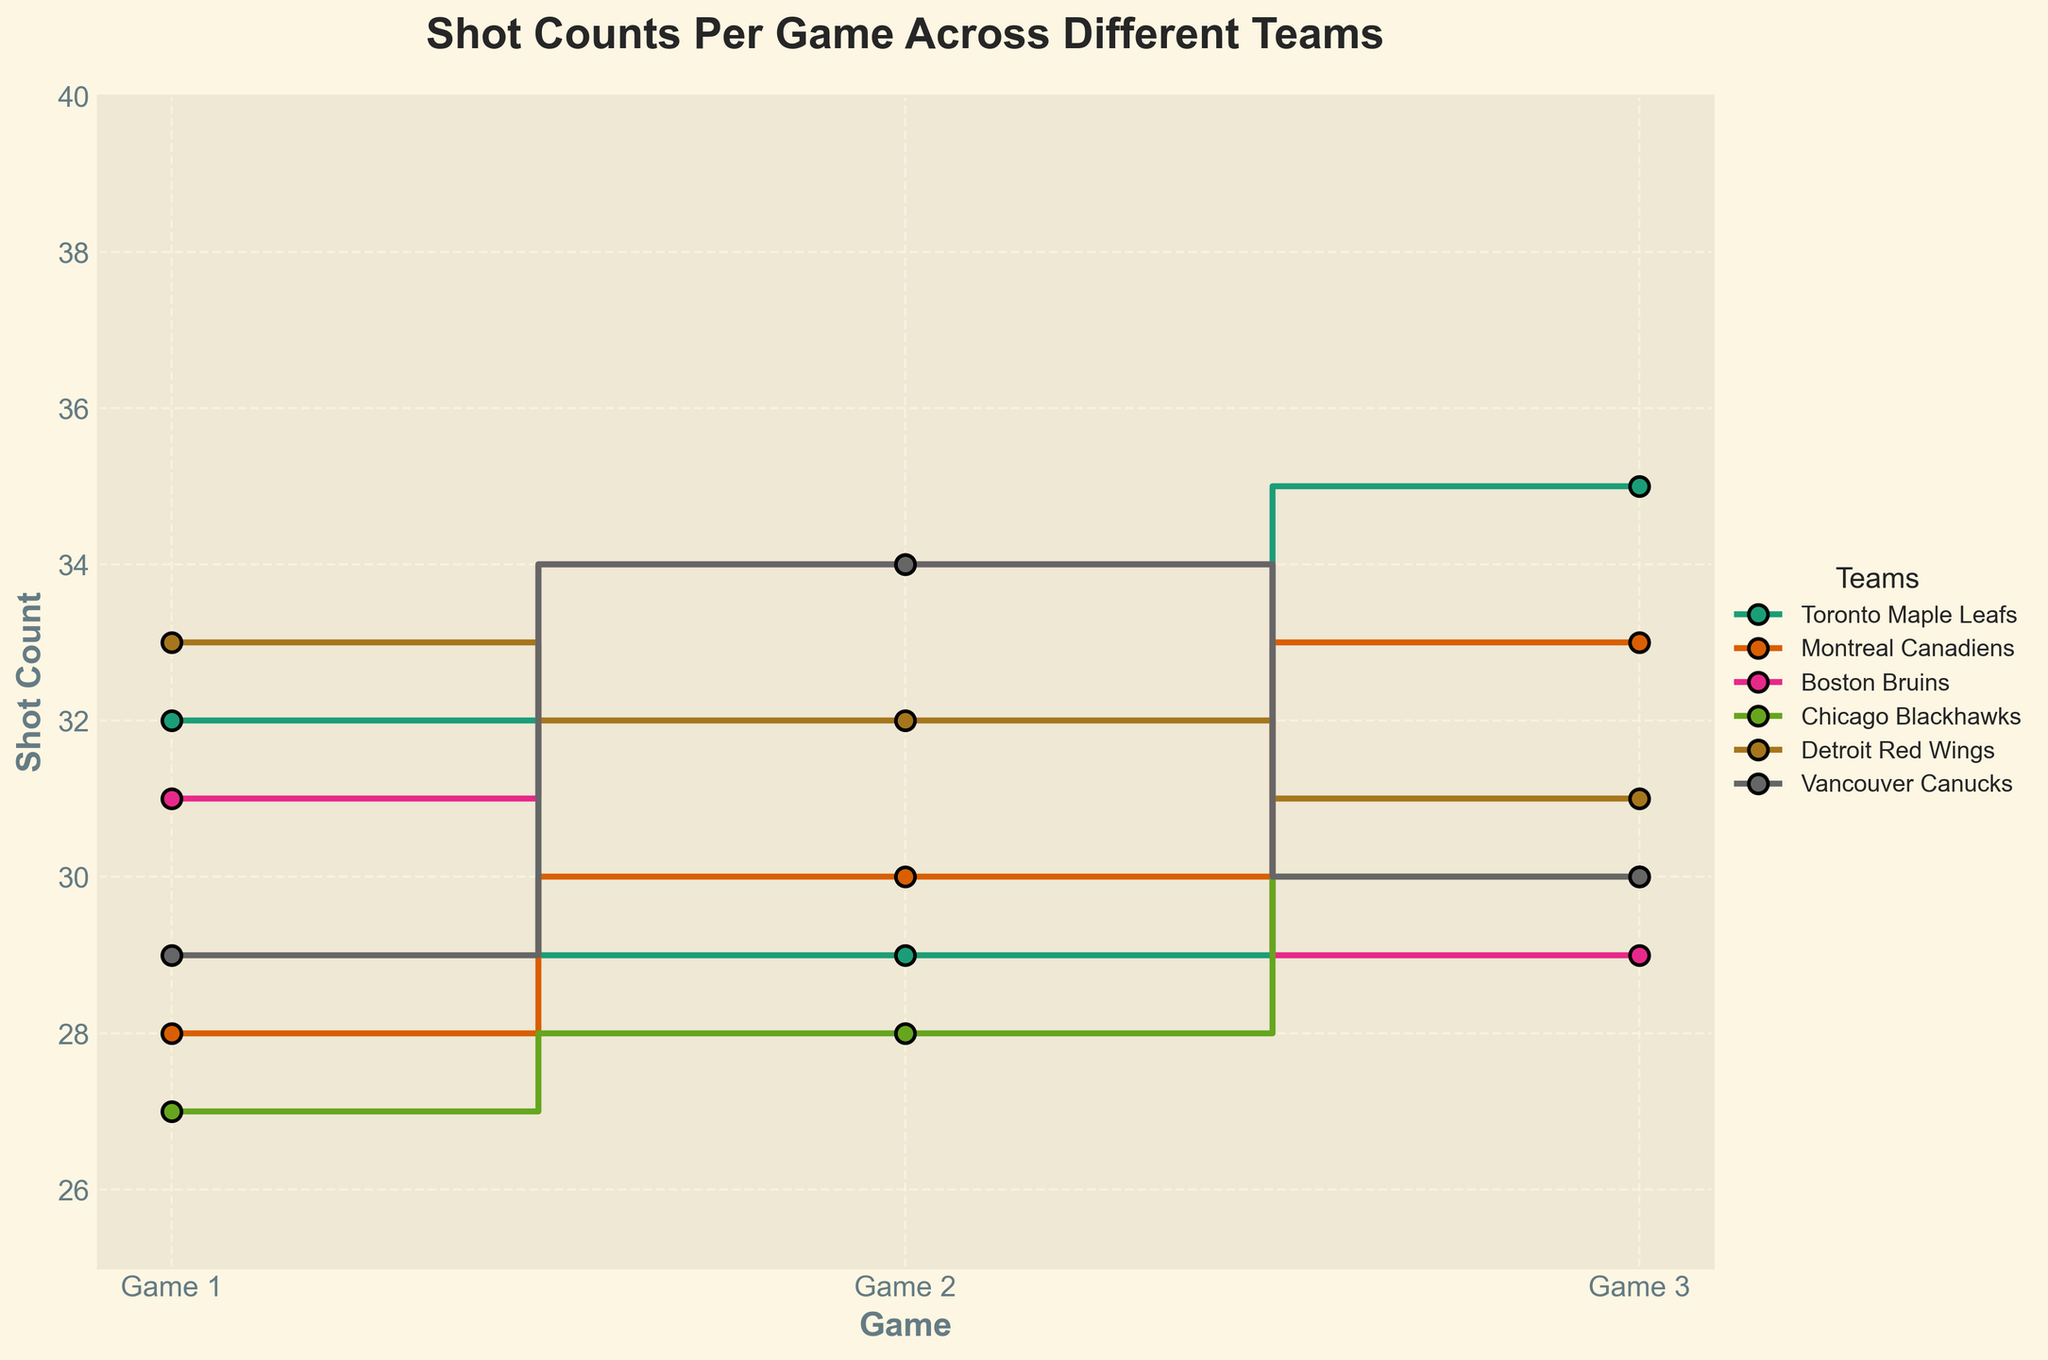Which team had the highest shot count in Game 1? Look for the data corresponding to Game 1 and find the team with the highest value. Toronto Maple Leafs had 32, Montreal Canadiens had 28, Boston Bruins had 31, Chicago Blackhawks had 27, Detroit Red Wings had 33, and Vancouver Canucks had 29. The highest is 33, achieved by Detroit Red Wings.
Answer: Detroit Red Wings Which team showed the most consistent shot count across the three games? Consistency can be judged by the smallest variations between the games. Calgary Flames had shot counts of 32, 29, and 35; counting the differences we get 3, 1, and 6. This process is done for all teams. The Boston Bruins had counts of 31, 34, and 29 with the respective differences being 3, 5, and 2, which averages to 3.33, the smallest average variation hence the most consistent.
Answer: Boston Bruins What is the total shot count for the Chicago Blackhawks across all three games? Sum the shot counts for the Chicago Blackhawks: 27 (Game 1) + 28 (Game 2) + 30 (Game 3) = 85
Answer: 85 Which team had the lowest shot count in Game 2? Look for the data corresponding to Game 2 and find the lowest value. Toronto Maple Leafs had 29, Montreal Canadiens had 30, Boston Bruins had 34, Chicago Blackhawks had 28, Detroit Red Wings had 32, and Vancouver Canucks had 34. The lowest is 28 by Chicago Blackhawks.
Answer: Chicago Blackhawks Between which games did the Toronto Maple Leafs see the greatest increase in shot count? Calculate the differences between consecutive games: 29 - 32 = -3 (Game 1 to Game 2) and 35 - 29 = 6 (Game 2 to Game 3). The greatest increase is 6 from Game 2 to Game 3.
Answer: Game 2 to Game 3 How many teams had a higher shot count in Game 3 compared to Game 1? Compare the values for Game 1 and Game 3 for each team: Toronto Maple Leafs (35 > 32), Montreal Canadiens (33 > 28), Boston Bruins (29 < 31), Chicago Blackhawks (30 > 27), Detroit Red Wings (31 < 33), Vancouver Canucks (30 > 29). Only three teams (Toronto Maple Leafs, Montreal Canadiens, Chicago Blackhawks) had higher counts.
Answer: 3 What is the average shot count for the Vancouver Canucks in the three games? Sum the shot counts for the Vancouver Canucks and divide by 3: (29 + 34 + 30) / 3 = 31
Answer: 31 Which team showed the largest drop in shot count between any two consecutive games? Calculate the drops for all teams and identify the largest: Toronto Maple Leafs' drop is 29 - 32 = -3, Montreal Canadiens' is never a drop, Boston Bruins is 34 - 29 = 5, Chicago Blackhawks' is never a drop, Detroit Red Wings' is 33 - 32 = -1. Boston Bruins had the largest drop of 5 from Game 2 to Game 3.
Answer: Boston Bruins 